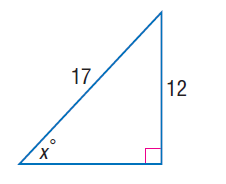Question: Find x.
Choices:
A. 44.9
B. 46.9
C. 57.1
D. 58.1
Answer with the letter. Answer: A 